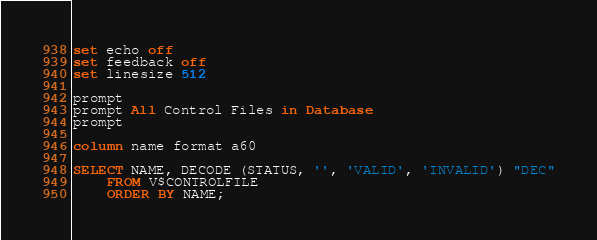<code> <loc_0><loc_0><loc_500><loc_500><_SQL_>set echo off
set feedback off
set linesize 512

prompt
prompt All Control Files in Database
prompt

column name format a60

SELECT NAME, DECODE (STATUS, '', 'VALID', 'INVALID') "DEC"
	FROM V$CONTROLFILE
	ORDER BY NAME;</code> 